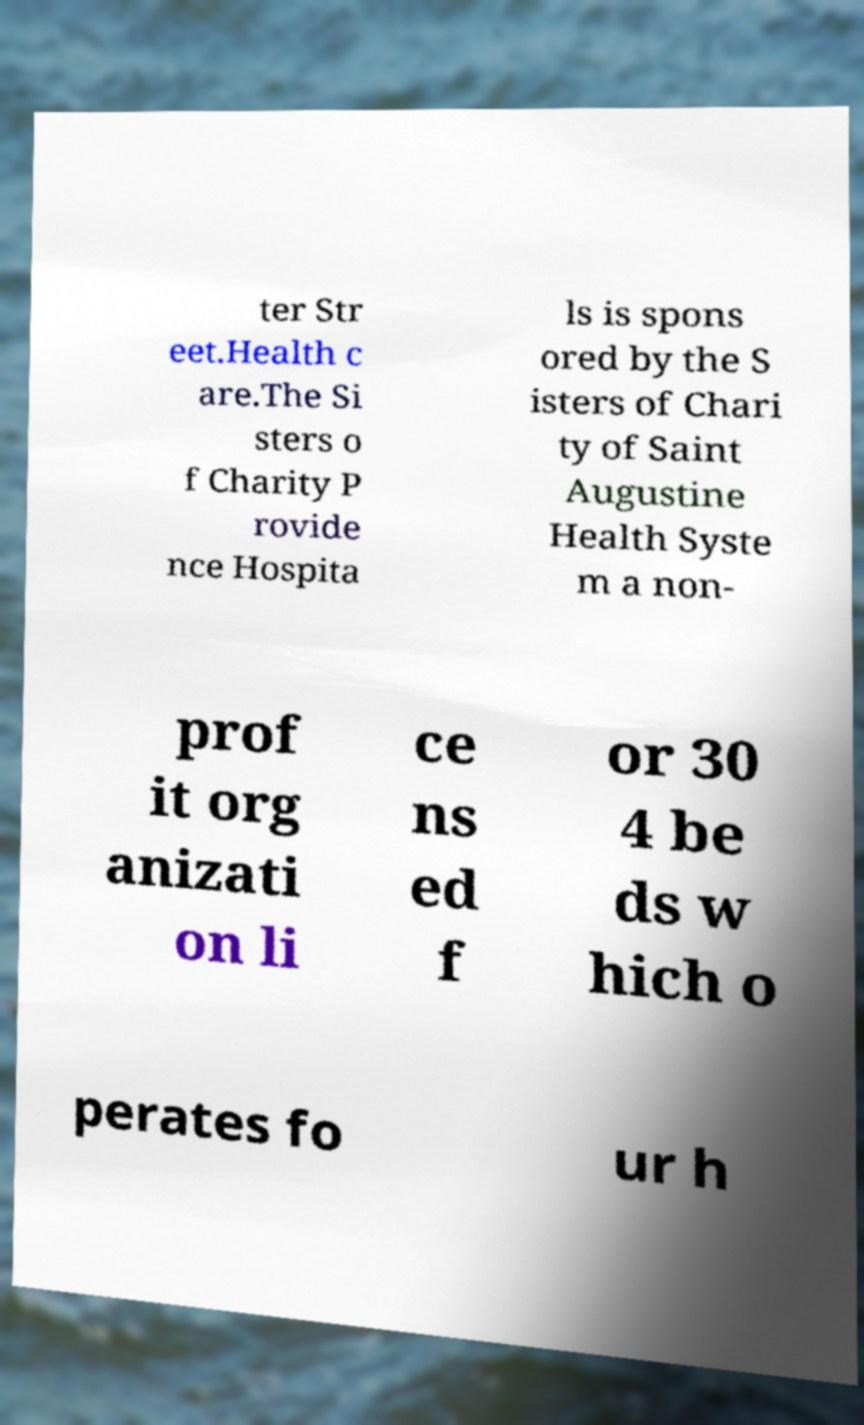For documentation purposes, I need the text within this image transcribed. Could you provide that? ter Str eet.Health c are.The Si sters o f Charity P rovide nce Hospita ls is spons ored by the S isters of Chari ty of Saint Augustine Health Syste m a non- prof it org anizati on li ce ns ed f or 30 4 be ds w hich o perates fo ur h 